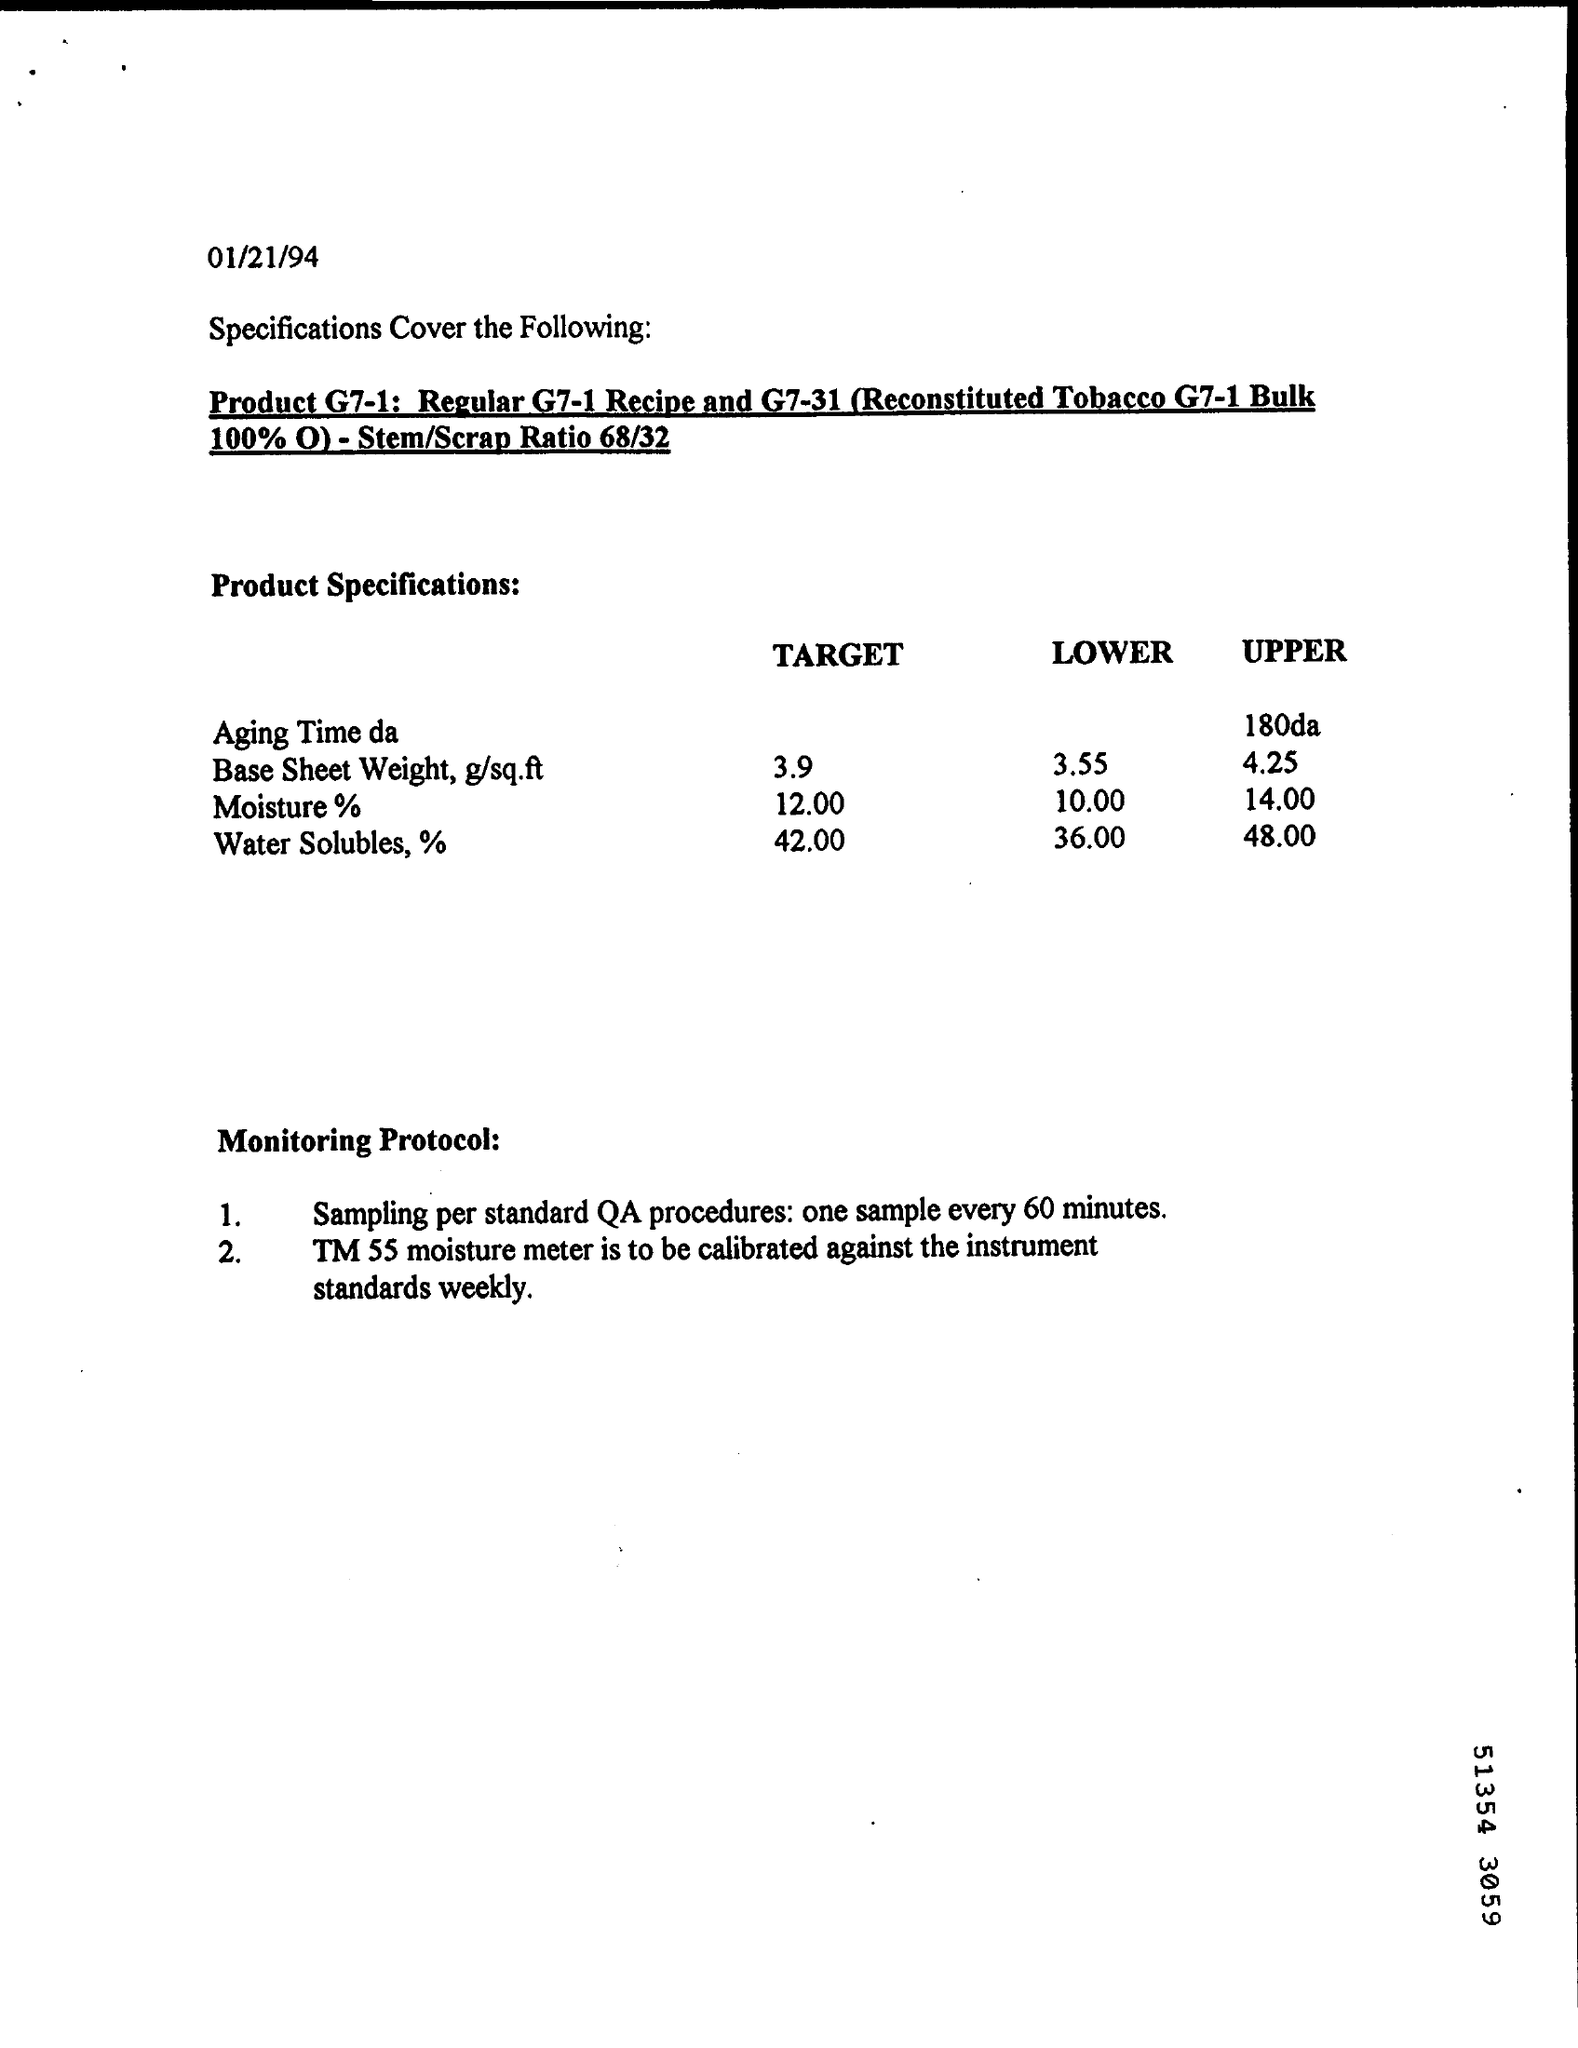Outline some significant characteristics in this image. The date mentioned is 01/21/94. The target value for water solubles, expressed as a percentage, is 42.00. The lower bound of the moisture percentage is 10.00%. 